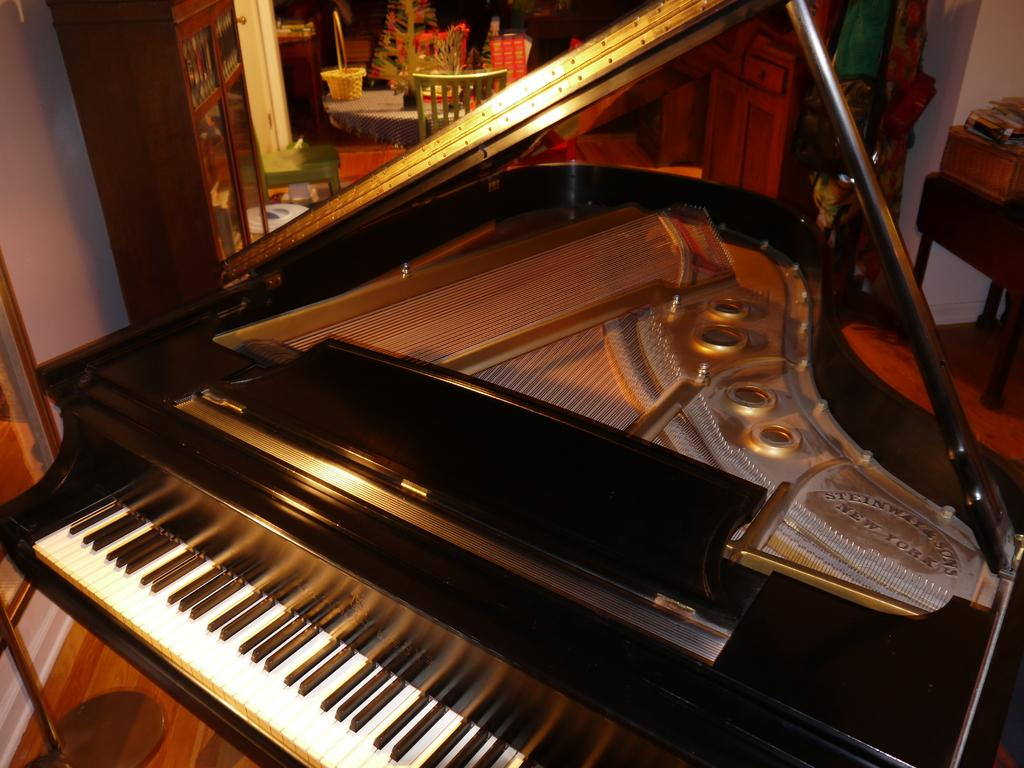What type of musical instrument is in the image? There is a black and white musical keyboard in the image. What piece of furniture is in the image that might be used for placing objects? There is a table in the image. What type of seating is in the image? There is a chair in the image. What is on top of the table in the image? There is a basket and a plant on the table in the image. How many pizzas are on the musical keyboard in the image? There are no pizzas on the musical keyboard in the image; it is a black and white keyboard. 